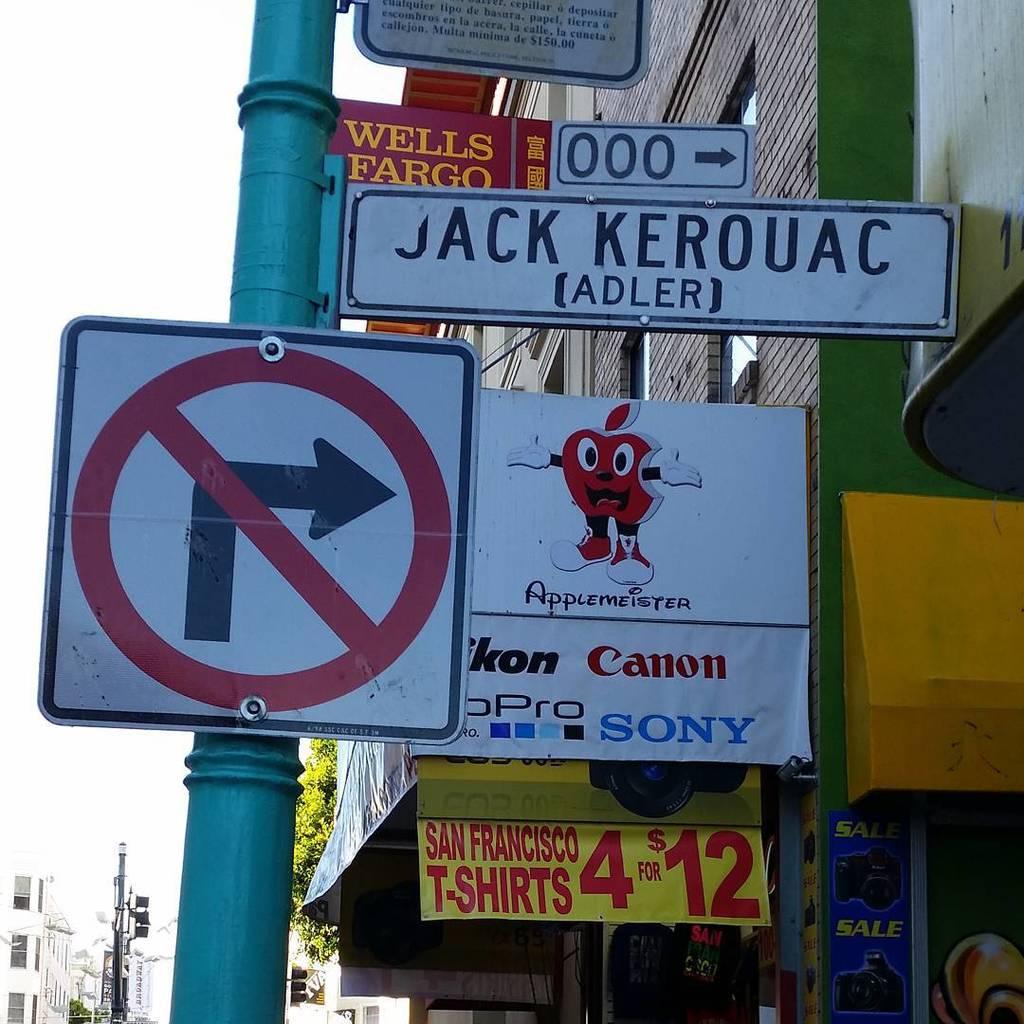How many san francisco t-shirts can you buy for $12?
Ensure brevity in your answer.  4. What is the name of this street?
Your answer should be very brief. Jack kerouac. 